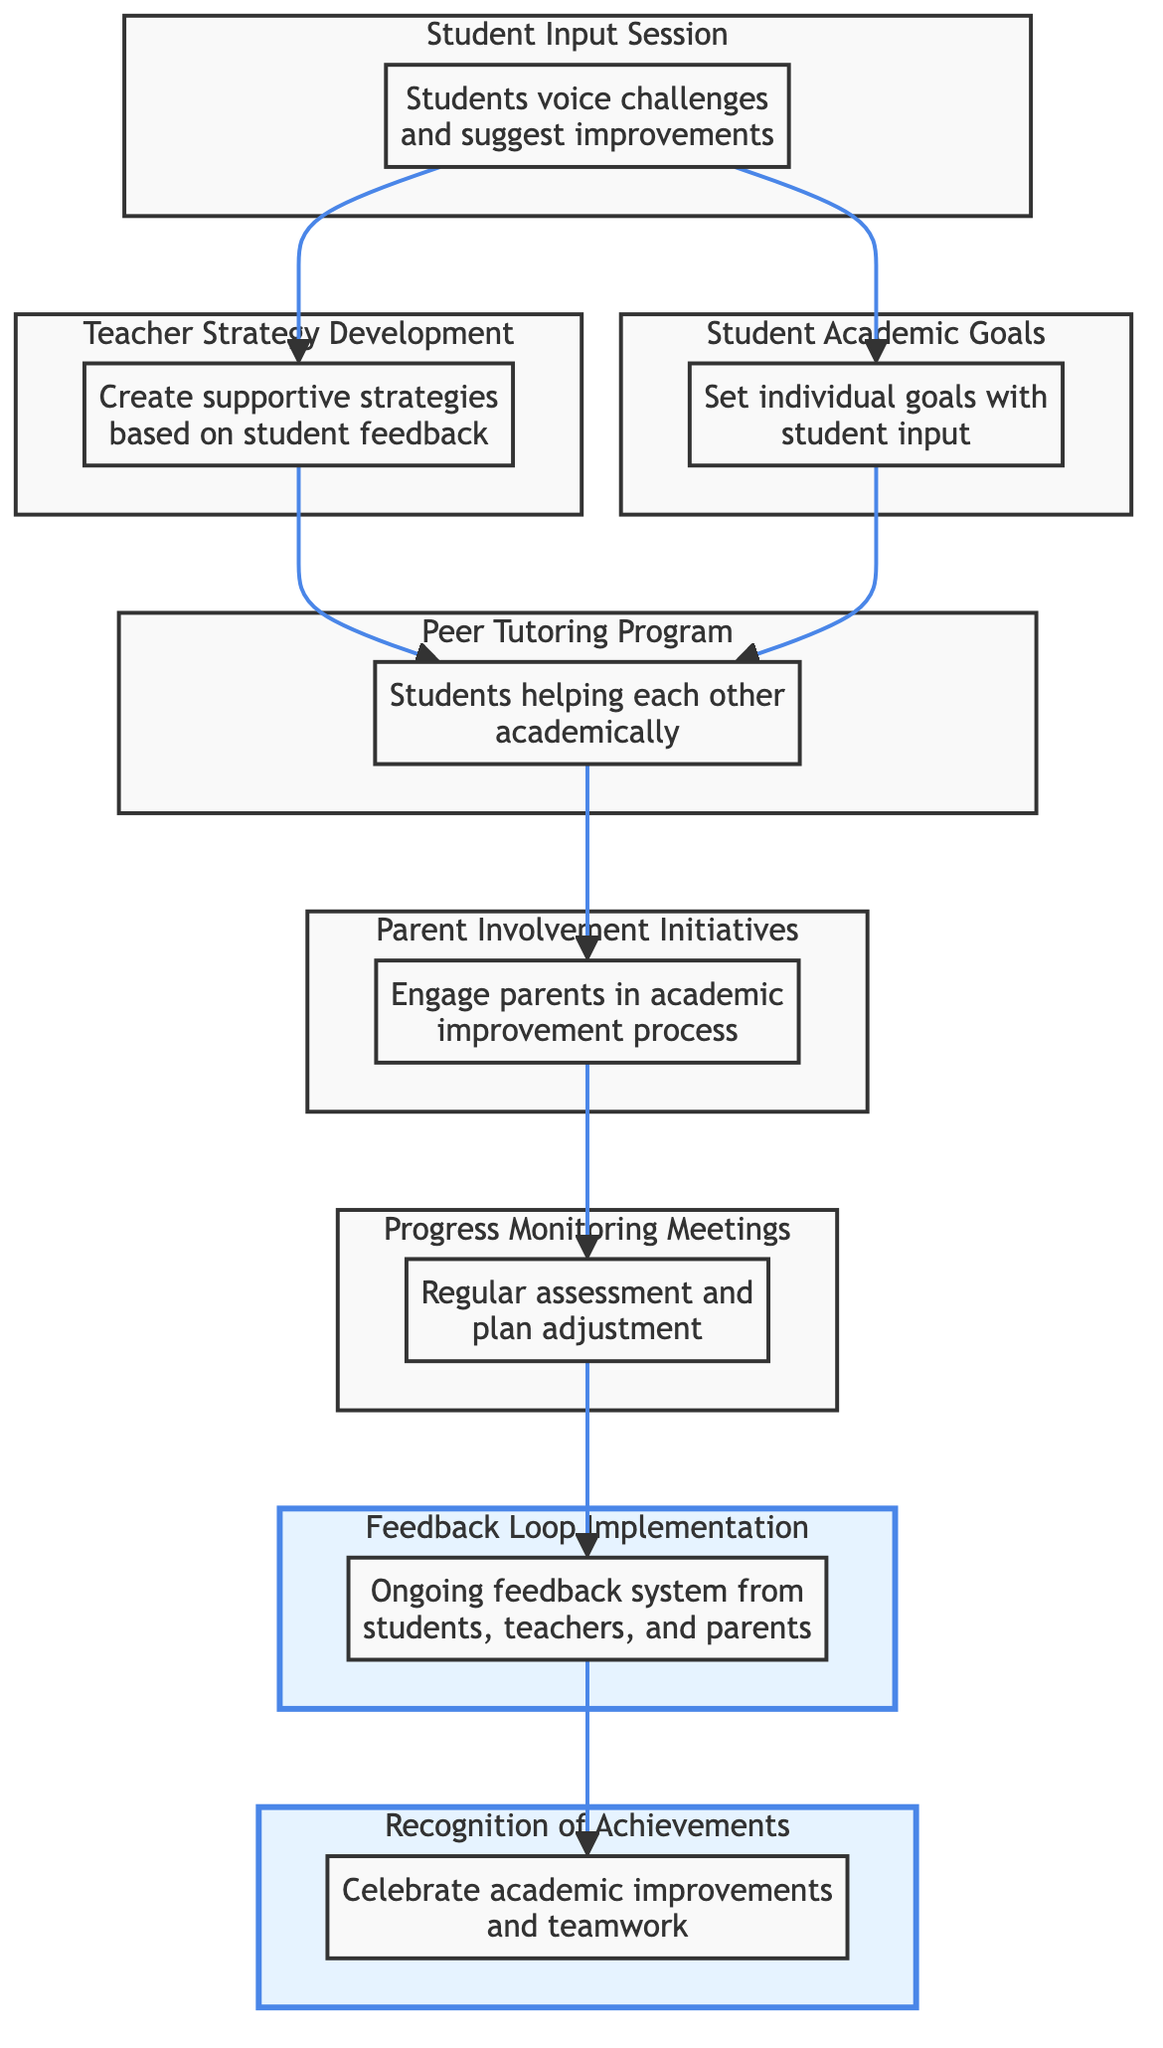What is the first step in the process? The first step is the "Student Input Session," where students can voice their academic challenges and suggest improvements.
Answer: Student Input Session How many key elements are there in the diagram? Counting all the distinct nodes, there are eight key elements represented in the diagram.
Answer: 8 What follows after the "Teacher Strategy Development"? After the "Teacher Strategy Development," the "Peer Tutoring Program" is established as a method to support students academically.
Answer: Peer Tutoring Program What is the purpose of the "Feedback Loop Implementation"? The purpose of the "Feedback Loop Implementation" is to create an ongoing feedback system from students, teachers, and parents to refine strategies.
Answer: Ongoing feedback system Which element connects "Progress Monitoring Meetings" to "Recognition of Achievements"? The "Feedback Loop Implementation" connects "Progress Monitoring Meetings" to "Recognition of Achievements," showing that the feedback gathered informs the recognition process.
Answer: Feedback Loop Implementation What element directly follows the "Peer Tutoring Program"? The "Parent Involvement Initiatives" follow the "Peer Tutoring Program," indicating a step to engage parents in the academic improvement process.
Answer: Parent Involvement Initiatives How does student input contribute to the plan? Student input contributes by informing the "Teacher Strategy Development" and the setting of "Student Academic Goals," ensuring their voices help shape the support strategies.
Answer: Teacher Strategy Development and Student Academic Goals What is the relationship between "Student Academic Goals" and "Peer Tutoring Program"? "Student Academic Goals" influence the "Peer Tutoring Program," as setting individual goals with student input encourages peer support among students with various academic needs.
Answer: Influence each other 